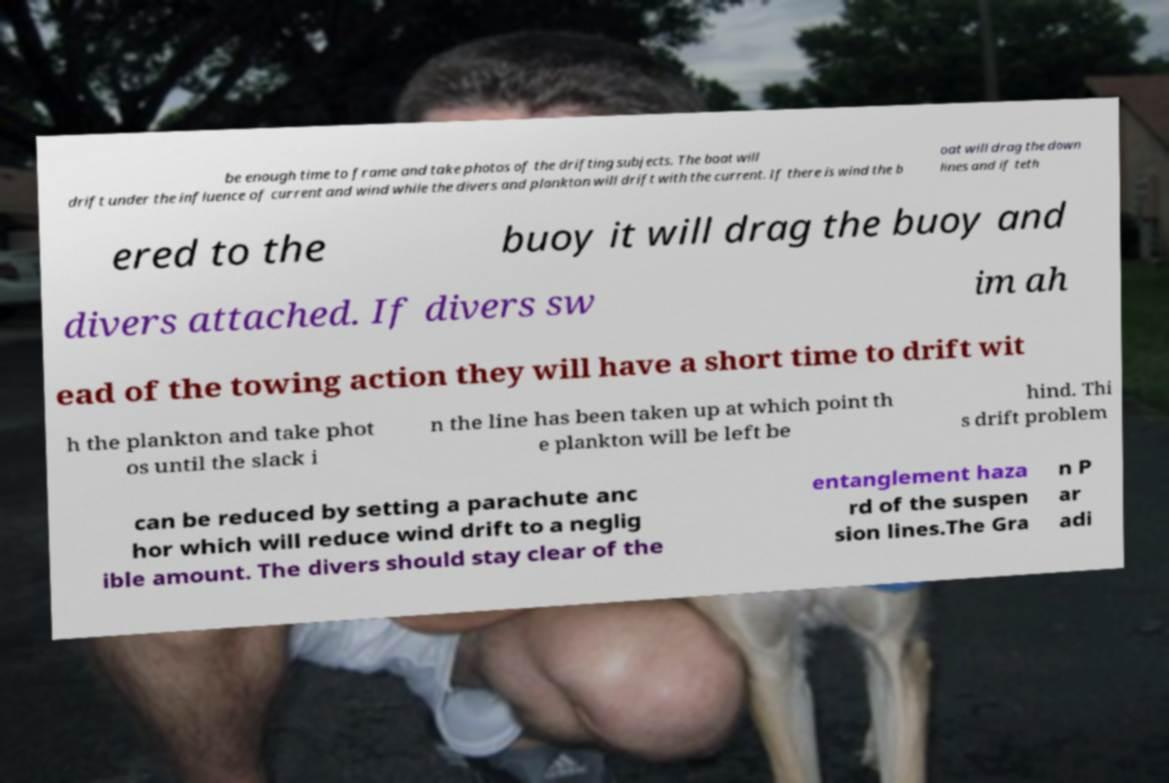Could you extract and type out the text from this image? be enough time to frame and take photos of the drifting subjects. The boat will drift under the influence of current and wind while the divers and plankton will drift with the current. If there is wind the b oat will drag the down lines and if teth ered to the buoy it will drag the buoy and divers attached. If divers sw im ah ead of the towing action they will have a short time to drift wit h the plankton and take phot os until the slack i n the line has been taken up at which point th e plankton will be left be hind. Thi s drift problem can be reduced by setting a parachute anc hor which will reduce wind drift to a neglig ible amount. The divers should stay clear of the entanglement haza rd of the suspen sion lines.The Gra n P ar adi 